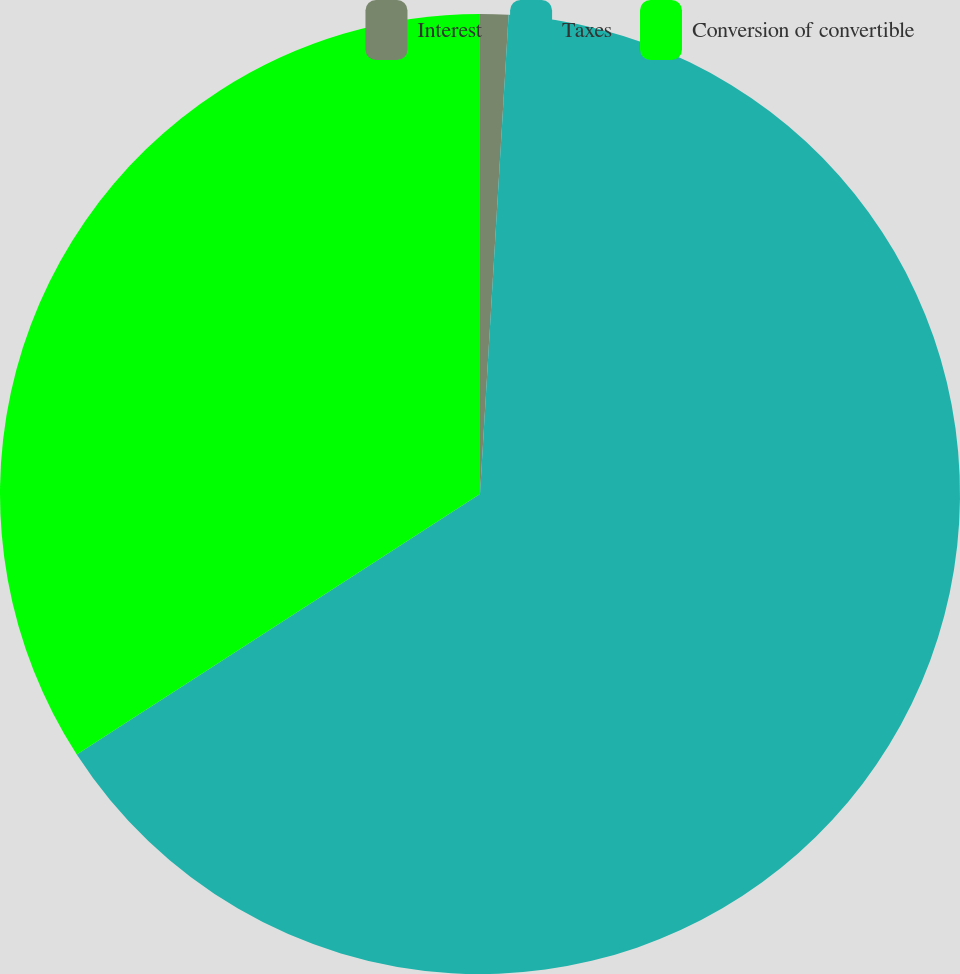Convert chart to OTSL. <chart><loc_0><loc_0><loc_500><loc_500><pie_chart><fcel>Interest<fcel>Taxes<fcel>Conversion of convertible<nl><fcel>0.95%<fcel>64.93%<fcel>34.13%<nl></chart> 